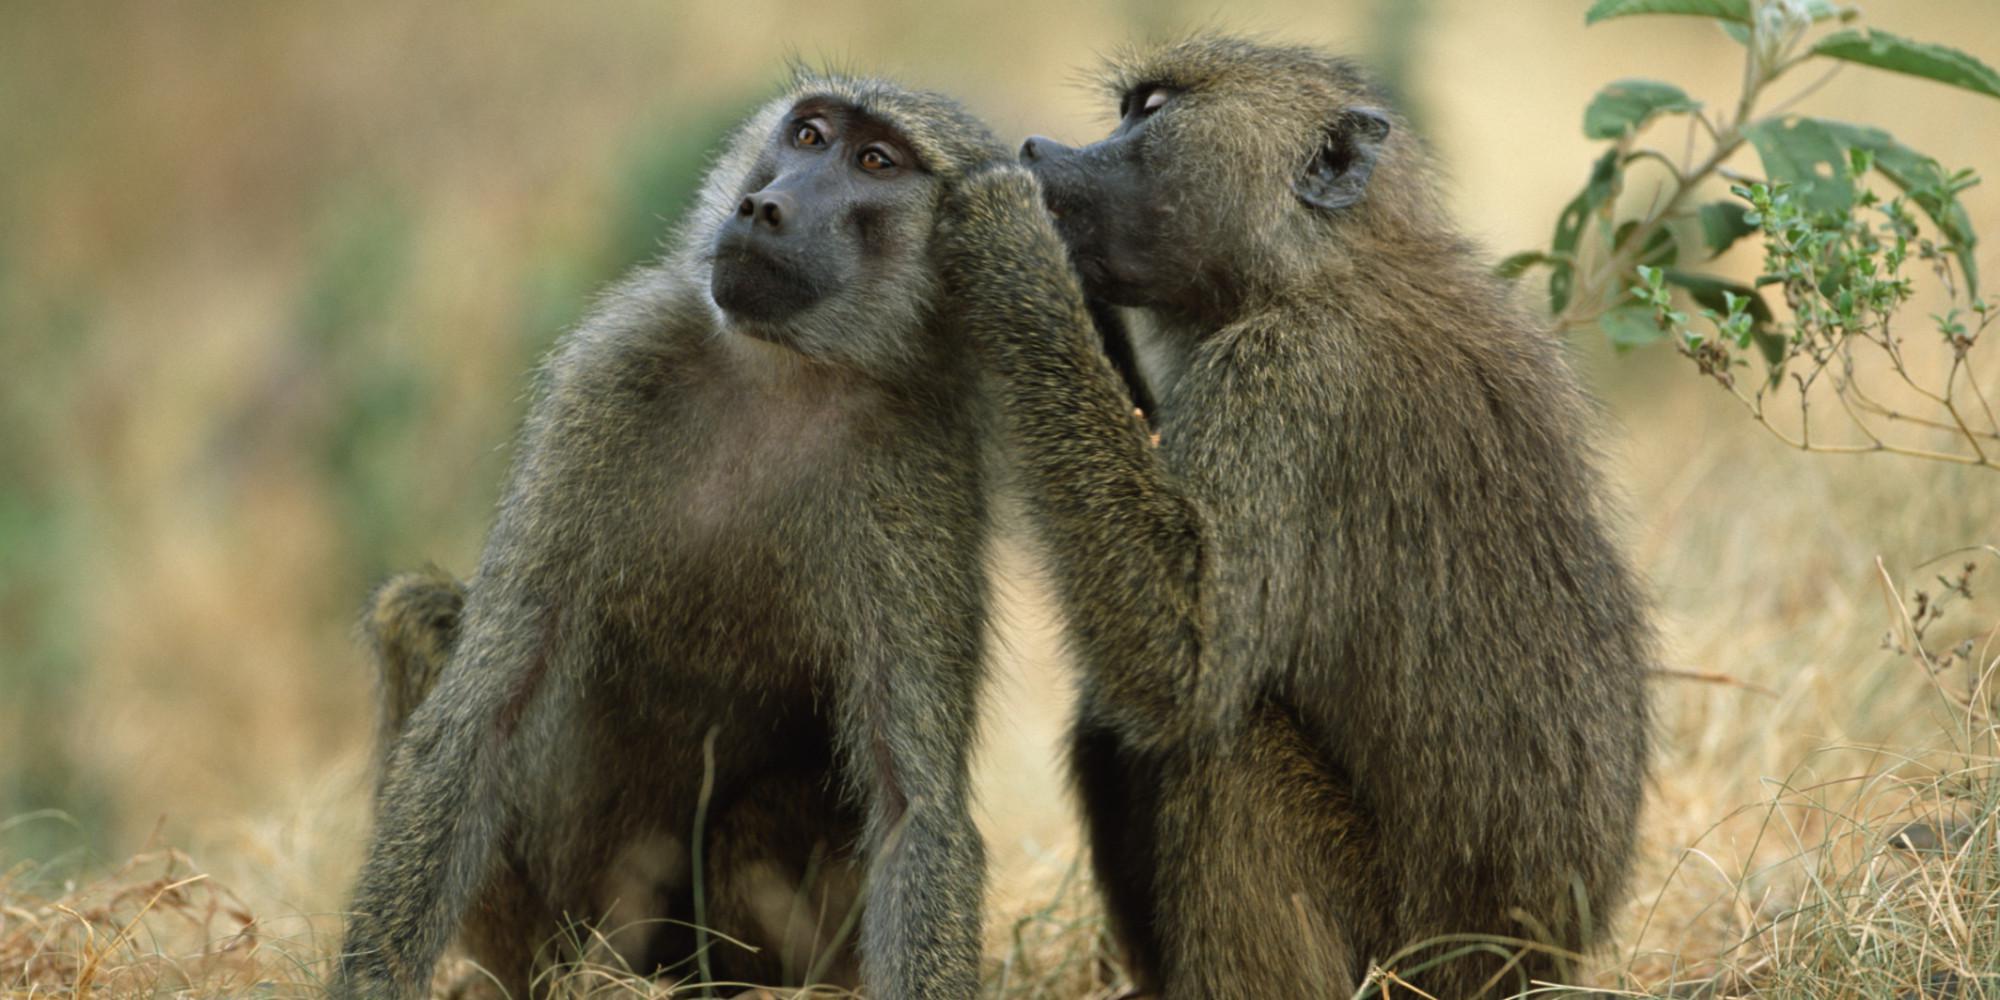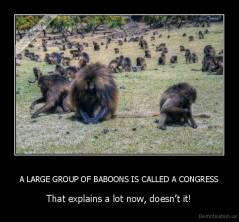The first image is the image on the left, the second image is the image on the right. Examine the images to the left and right. Is the description "Each image contains exactly one monkey, and the monkeys on the right and left are the same approximate age [mature or immature]." accurate? Answer yes or no. No. 